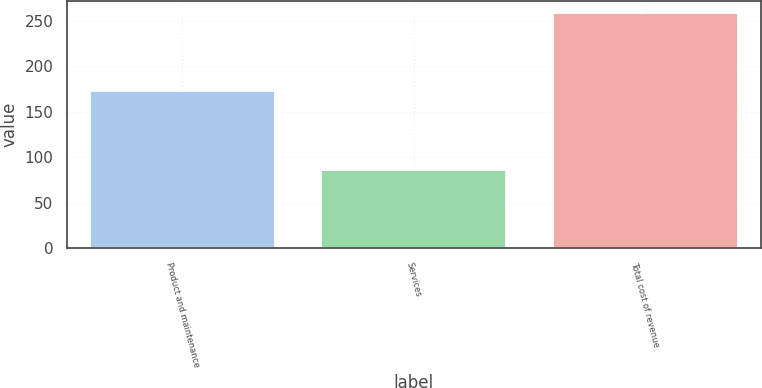Convert chart. <chart><loc_0><loc_0><loc_500><loc_500><bar_chart><fcel>Product and maintenance<fcel>Services<fcel>Total cost of revenue<nl><fcel>173<fcel>85.7<fcel>258.7<nl></chart> 